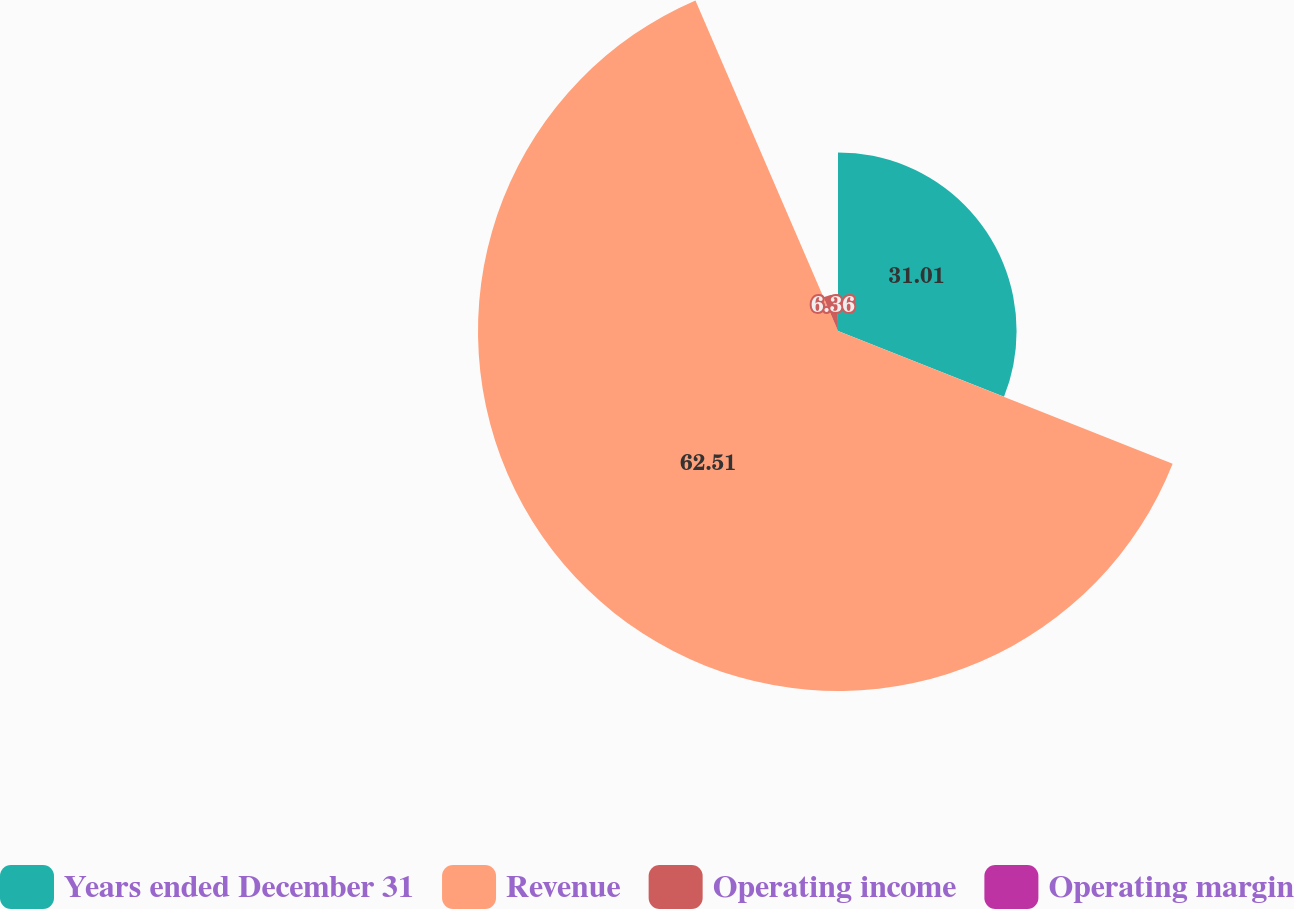Convert chart. <chart><loc_0><loc_0><loc_500><loc_500><pie_chart><fcel>Years ended December 31<fcel>Revenue<fcel>Operating income<fcel>Operating margin<nl><fcel>31.01%<fcel>62.51%<fcel>6.36%<fcel>0.12%<nl></chart> 